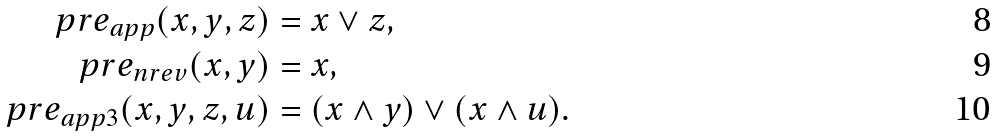Convert formula to latex. <formula><loc_0><loc_0><loc_500><loc_500>\ p r e _ { a p p } ( x , y , z ) & = x \lor z , \\ \ p r e _ { n r e v } ( x , y ) & = x , \\ \ p r e _ { a p p 3 } ( x , y , z , u ) & = ( x \land y ) \lor ( x \land u ) .</formula> 